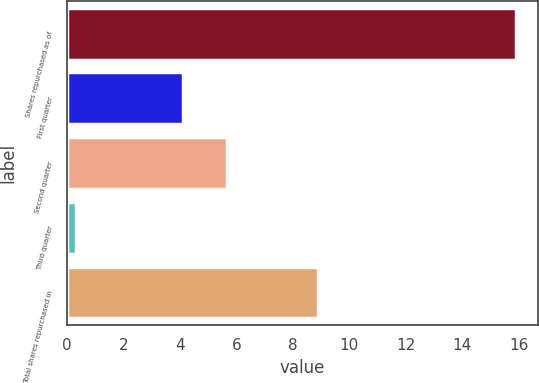Convert chart to OTSL. <chart><loc_0><loc_0><loc_500><loc_500><bar_chart><fcel>Shares repurchased as of<fcel>First quarter<fcel>Second quarter<fcel>Third quarter<fcel>Total shares repurchased in<nl><fcel>15.9<fcel>4.1<fcel>5.66<fcel>0.3<fcel>8.9<nl></chart> 